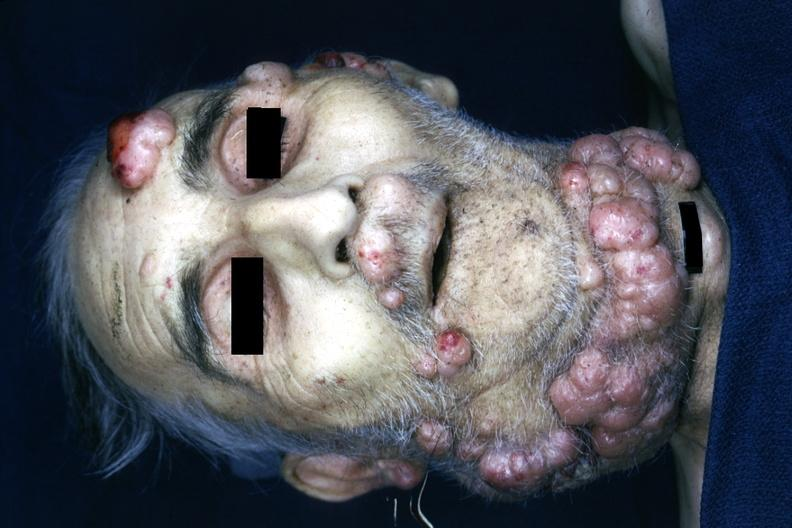what does von recklinghausen?
Answer the question using a single word or phrase. Disease is present 